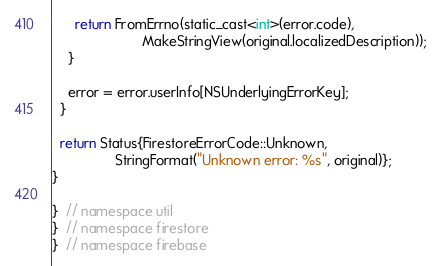Convert code to text. <code><loc_0><loc_0><loc_500><loc_500><_ObjectiveC_>      return FromErrno(static_cast<int>(error.code),
                       MakeStringView(original.localizedDescription));
    }

    error = error.userInfo[NSUnderlyingErrorKey];
  }

  return Status{FirestoreErrorCode::Unknown,
                StringFormat("Unknown error: %s", original)};
}

}  // namespace util
}  // namespace firestore
}  // namespace firebase
</code> 